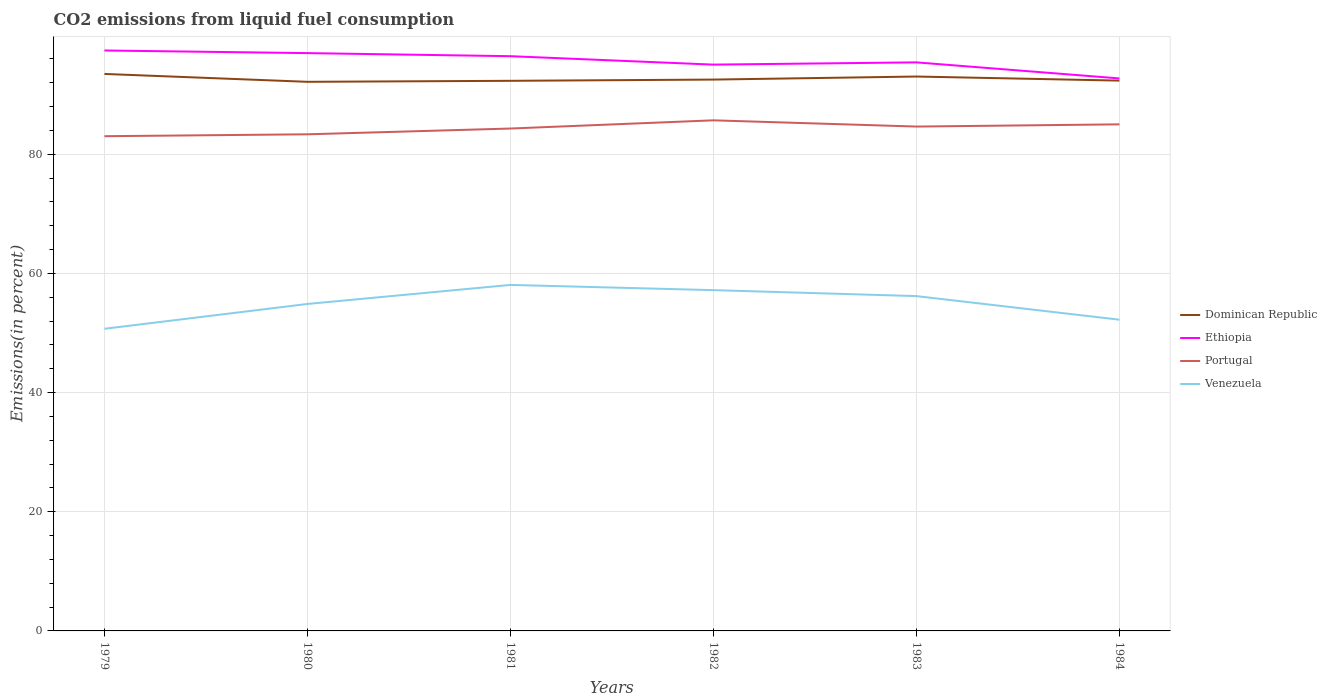How many different coloured lines are there?
Offer a terse response. 4. Does the line corresponding to Dominican Republic intersect with the line corresponding to Venezuela?
Make the answer very short. No. Across all years, what is the maximum total CO2 emitted in Ethiopia?
Ensure brevity in your answer.  92.73. In which year was the total CO2 emitted in Venezuela maximum?
Your response must be concise. 1979. What is the total total CO2 emitted in Portugal in the graph?
Ensure brevity in your answer.  -1.37. What is the difference between the highest and the second highest total CO2 emitted in Portugal?
Ensure brevity in your answer.  2.66. What is the difference between the highest and the lowest total CO2 emitted in Venezuela?
Your answer should be compact. 3. Is the total CO2 emitted in Dominican Republic strictly greater than the total CO2 emitted in Ethiopia over the years?
Make the answer very short. Yes. How many years are there in the graph?
Keep it short and to the point. 6. Are the values on the major ticks of Y-axis written in scientific E-notation?
Give a very brief answer. No. Does the graph contain any zero values?
Provide a short and direct response. No. How are the legend labels stacked?
Ensure brevity in your answer.  Vertical. What is the title of the graph?
Offer a very short reply. CO2 emissions from liquid fuel consumption. What is the label or title of the X-axis?
Give a very brief answer. Years. What is the label or title of the Y-axis?
Your answer should be very brief. Emissions(in percent). What is the Emissions(in percent) of Dominican Republic in 1979?
Offer a very short reply. 93.48. What is the Emissions(in percent) of Ethiopia in 1979?
Make the answer very short. 97.42. What is the Emissions(in percent) of Portugal in 1979?
Provide a succinct answer. 83.04. What is the Emissions(in percent) in Venezuela in 1979?
Offer a very short reply. 50.71. What is the Emissions(in percent) in Dominican Republic in 1980?
Keep it short and to the point. 92.16. What is the Emissions(in percent) in Ethiopia in 1980?
Provide a short and direct response. 96.98. What is the Emissions(in percent) in Portugal in 1980?
Provide a succinct answer. 83.35. What is the Emissions(in percent) in Venezuela in 1980?
Your answer should be compact. 54.88. What is the Emissions(in percent) of Dominican Republic in 1981?
Provide a succinct answer. 92.33. What is the Emissions(in percent) of Ethiopia in 1981?
Provide a short and direct response. 96.46. What is the Emissions(in percent) in Portugal in 1981?
Your response must be concise. 84.32. What is the Emissions(in percent) of Venezuela in 1981?
Make the answer very short. 58.07. What is the Emissions(in percent) in Dominican Republic in 1982?
Your response must be concise. 92.54. What is the Emissions(in percent) in Ethiopia in 1982?
Provide a short and direct response. 95.05. What is the Emissions(in percent) in Portugal in 1982?
Keep it short and to the point. 85.7. What is the Emissions(in percent) of Venezuela in 1982?
Offer a very short reply. 57.2. What is the Emissions(in percent) of Dominican Republic in 1983?
Offer a very short reply. 93.05. What is the Emissions(in percent) in Ethiopia in 1983?
Offer a terse response. 95.43. What is the Emissions(in percent) in Portugal in 1983?
Your answer should be compact. 84.65. What is the Emissions(in percent) in Venezuela in 1983?
Keep it short and to the point. 56.2. What is the Emissions(in percent) in Dominican Republic in 1984?
Your answer should be very brief. 92.36. What is the Emissions(in percent) of Ethiopia in 1984?
Keep it short and to the point. 92.73. What is the Emissions(in percent) of Portugal in 1984?
Make the answer very short. 85.02. What is the Emissions(in percent) in Venezuela in 1984?
Provide a succinct answer. 52.24. Across all years, what is the maximum Emissions(in percent) in Dominican Republic?
Provide a succinct answer. 93.48. Across all years, what is the maximum Emissions(in percent) of Ethiopia?
Make the answer very short. 97.42. Across all years, what is the maximum Emissions(in percent) in Portugal?
Provide a succinct answer. 85.7. Across all years, what is the maximum Emissions(in percent) in Venezuela?
Offer a very short reply. 58.07. Across all years, what is the minimum Emissions(in percent) of Dominican Republic?
Your answer should be very brief. 92.16. Across all years, what is the minimum Emissions(in percent) in Ethiopia?
Offer a terse response. 92.73. Across all years, what is the minimum Emissions(in percent) of Portugal?
Your response must be concise. 83.04. Across all years, what is the minimum Emissions(in percent) of Venezuela?
Provide a succinct answer. 50.71. What is the total Emissions(in percent) of Dominican Republic in the graph?
Keep it short and to the point. 555.93. What is the total Emissions(in percent) in Ethiopia in the graph?
Your answer should be compact. 574.07. What is the total Emissions(in percent) of Portugal in the graph?
Give a very brief answer. 506.09. What is the total Emissions(in percent) in Venezuela in the graph?
Give a very brief answer. 329.29. What is the difference between the Emissions(in percent) of Dominican Republic in 1979 and that in 1980?
Offer a very short reply. 1.32. What is the difference between the Emissions(in percent) in Ethiopia in 1979 and that in 1980?
Offer a very short reply. 0.44. What is the difference between the Emissions(in percent) in Portugal in 1979 and that in 1980?
Your answer should be compact. -0.32. What is the difference between the Emissions(in percent) of Venezuela in 1979 and that in 1980?
Your answer should be compact. -4.17. What is the difference between the Emissions(in percent) in Dominican Republic in 1979 and that in 1981?
Offer a very short reply. 1.15. What is the difference between the Emissions(in percent) in Ethiopia in 1979 and that in 1981?
Offer a very short reply. 0.96. What is the difference between the Emissions(in percent) of Portugal in 1979 and that in 1981?
Keep it short and to the point. -1.29. What is the difference between the Emissions(in percent) in Venezuela in 1979 and that in 1981?
Your answer should be compact. -7.36. What is the difference between the Emissions(in percent) of Dominican Republic in 1979 and that in 1982?
Offer a very short reply. 0.95. What is the difference between the Emissions(in percent) of Ethiopia in 1979 and that in 1982?
Offer a terse response. 2.37. What is the difference between the Emissions(in percent) of Portugal in 1979 and that in 1982?
Keep it short and to the point. -2.66. What is the difference between the Emissions(in percent) in Venezuela in 1979 and that in 1982?
Provide a short and direct response. -6.49. What is the difference between the Emissions(in percent) in Dominican Republic in 1979 and that in 1983?
Your answer should be compact. 0.43. What is the difference between the Emissions(in percent) of Ethiopia in 1979 and that in 1983?
Make the answer very short. 1.99. What is the difference between the Emissions(in percent) in Portugal in 1979 and that in 1983?
Make the answer very short. -1.62. What is the difference between the Emissions(in percent) of Venezuela in 1979 and that in 1983?
Make the answer very short. -5.49. What is the difference between the Emissions(in percent) in Dominican Republic in 1979 and that in 1984?
Keep it short and to the point. 1.12. What is the difference between the Emissions(in percent) of Ethiopia in 1979 and that in 1984?
Your response must be concise. 4.69. What is the difference between the Emissions(in percent) in Portugal in 1979 and that in 1984?
Ensure brevity in your answer.  -1.99. What is the difference between the Emissions(in percent) in Venezuela in 1979 and that in 1984?
Provide a short and direct response. -1.53. What is the difference between the Emissions(in percent) of Dominican Republic in 1980 and that in 1981?
Your response must be concise. -0.17. What is the difference between the Emissions(in percent) of Ethiopia in 1980 and that in 1981?
Make the answer very short. 0.52. What is the difference between the Emissions(in percent) in Portugal in 1980 and that in 1981?
Give a very brief answer. -0.97. What is the difference between the Emissions(in percent) in Venezuela in 1980 and that in 1981?
Make the answer very short. -3.2. What is the difference between the Emissions(in percent) of Dominican Republic in 1980 and that in 1982?
Your response must be concise. -0.38. What is the difference between the Emissions(in percent) in Ethiopia in 1980 and that in 1982?
Keep it short and to the point. 1.93. What is the difference between the Emissions(in percent) in Portugal in 1980 and that in 1982?
Offer a very short reply. -2.34. What is the difference between the Emissions(in percent) in Venezuela in 1980 and that in 1982?
Offer a very short reply. -2.32. What is the difference between the Emissions(in percent) in Dominican Republic in 1980 and that in 1983?
Your answer should be very brief. -0.89. What is the difference between the Emissions(in percent) of Ethiopia in 1980 and that in 1983?
Ensure brevity in your answer.  1.55. What is the difference between the Emissions(in percent) of Portugal in 1980 and that in 1983?
Offer a terse response. -1.3. What is the difference between the Emissions(in percent) in Venezuela in 1980 and that in 1983?
Keep it short and to the point. -1.32. What is the difference between the Emissions(in percent) in Dominican Republic in 1980 and that in 1984?
Give a very brief answer. -0.2. What is the difference between the Emissions(in percent) in Ethiopia in 1980 and that in 1984?
Your answer should be very brief. 4.25. What is the difference between the Emissions(in percent) in Portugal in 1980 and that in 1984?
Your answer should be compact. -1.67. What is the difference between the Emissions(in percent) of Venezuela in 1980 and that in 1984?
Your answer should be very brief. 2.64. What is the difference between the Emissions(in percent) of Dominican Republic in 1981 and that in 1982?
Your answer should be very brief. -0.21. What is the difference between the Emissions(in percent) of Ethiopia in 1981 and that in 1982?
Offer a terse response. 1.41. What is the difference between the Emissions(in percent) in Portugal in 1981 and that in 1982?
Give a very brief answer. -1.37. What is the difference between the Emissions(in percent) in Venezuela in 1981 and that in 1982?
Offer a very short reply. 0.88. What is the difference between the Emissions(in percent) in Dominican Republic in 1981 and that in 1983?
Your answer should be very brief. -0.72. What is the difference between the Emissions(in percent) in Ethiopia in 1981 and that in 1983?
Ensure brevity in your answer.  1.04. What is the difference between the Emissions(in percent) in Portugal in 1981 and that in 1983?
Your answer should be very brief. -0.33. What is the difference between the Emissions(in percent) in Venezuela in 1981 and that in 1983?
Offer a terse response. 1.88. What is the difference between the Emissions(in percent) in Dominican Republic in 1981 and that in 1984?
Make the answer very short. -0.03. What is the difference between the Emissions(in percent) in Ethiopia in 1981 and that in 1984?
Give a very brief answer. 3.73. What is the difference between the Emissions(in percent) in Portugal in 1981 and that in 1984?
Your response must be concise. -0.7. What is the difference between the Emissions(in percent) of Venezuela in 1981 and that in 1984?
Offer a very short reply. 5.84. What is the difference between the Emissions(in percent) of Dominican Republic in 1982 and that in 1983?
Your response must be concise. -0.51. What is the difference between the Emissions(in percent) in Ethiopia in 1982 and that in 1983?
Ensure brevity in your answer.  -0.38. What is the difference between the Emissions(in percent) in Portugal in 1982 and that in 1983?
Offer a terse response. 1.04. What is the difference between the Emissions(in percent) in Venezuela in 1982 and that in 1983?
Make the answer very short. 1. What is the difference between the Emissions(in percent) of Dominican Republic in 1982 and that in 1984?
Keep it short and to the point. 0.17. What is the difference between the Emissions(in percent) in Ethiopia in 1982 and that in 1984?
Offer a terse response. 2.32. What is the difference between the Emissions(in percent) of Portugal in 1982 and that in 1984?
Your answer should be compact. 0.67. What is the difference between the Emissions(in percent) in Venezuela in 1982 and that in 1984?
Your answer should be very brief. 4.96. What is the difference between the Emissions(in percent) of Dominican Republic in 1983 and that in 1984?
Make the answer very short. 0.68. What is the difference between the Emissions(in percent) of Ethiopia in 1983 and that in 1984?
Your answer should be very brief. 2.7. What is the difference between the Emissions(in percent) in Portugal in 1983 and that in 1984?
Make the answer very short. -0.37. What is the difference between the Emissions(in percent) in Venezuela in 1983 and that in 1984?
Provide a short and direct response. 3.96. What is the difference between the Emissions(in percent) of Dominican Republic in 1979 and the Emissions(in percent) of Ethiopia in 1980?
Offer a very short reply. -3.5. What is the difference between the Emissions(in percent) of Dominican Republic in 1979 and the Emissions(in percent) of Portugal in 1980?
Keep it short and to the point. 10.13. What is the difference between the Emissions(in percent) of Dominican Republic in 1979 and the Emissions(in percent) of Venezuela in 1980?
Ensure brevity in your answer.  38.61. What is the difference between the Emissions(in percent) of Ethiopia in 1979 and the Emissions(in percent) of Portugal in 1980?
Give a very brief answer. 14.07. What is the difference between the Emissions(in percent) in Ethiopia in 1979 and the Emissions(in percent) in Venezuela in 1980?
Ensure brevity in your answer.  42.54. What is the difference between the Emissions(in percent) of Portugal in 1979 and the Emissions(in percent) of Venezuela in 1980?
Your answer should be compact. 28.16. What is the difference between the Emissions(in percent) of Dominican Republic in 1979 and the Emissions(in percent) of Ethiopia in 1981?
Keep it short and to the point. -2.98. What is the difference between the Emissions(in percent) in Dominican Republic in 1979 and the Emissions(in percent) in Portugal in 1981?
Your response must be concise. 9.16. What is the difference between the Emissions(in percent) in Dominican Republic in 1979 and the Emissions(in percent) in Venezuela in 1981?
Make the answer very short. 35.41. What is the difference between the Emissions(in percent) in Ethiopia in 1979 and the Emissions(in percent) in Portugal in 1981?
Your answer should be compact. 13.1. What is the difference between the Emissions(in percent) of Ethiopia in 1979 and the Emissions(in percent) of Venezuela in 1981?
Offer a terse response. 39.35. What is the difference between the Emissions(in percent) of Portugal in 1979 and the Emissions(in percent) of Venezuela in 1981?
Make the answer very short. 24.96. What is the difference between the Emissions(in percent) in Dominican Republic in 1979 and the Emissions(in percent) in Ethiopia in 1982?
Offer a very short reply. -1.57. What is the difference between the Emissions(in percent) in Dominican Republic in 1979 and the Emissions(in percent) in Portugal in 1982?
Make the answer very short. 7.79. What is the difference between the Emissions(in percent) in Dominican Republic in 1979 and the Emissions(in percent) in Venezuela in 1982?
Your answer should be compact. 36.29. What is the difference between the Emissions(in percent) in Ethiopia in 1979 and the Emissions(in percent) in Portugal in 1982?
Give a very brief answer. 11.72. What is the difference between the Emissions(in percent) in Ethiopia in 1979 and the Emissions(in percent) in Venezuela in 1982?
Your response must be concise. 40.22. What is the difference between the Emissions(in percent) in Portugal in 1979 and the Emissions(in percent) in Venezuela in 1982?
Your response must be concise. 25.84. What is the difference between the Emissions(in percent) in Dominican Republic in 1979 and the Emissions(in percent) in Ethiopia in 1983?
Keep it short and to the point. -1.94. What is the difference between the Emissions(in percent) of Dominican Republic in 1979 and the Emissions(in percent) of Portugal in 1983?
Keep it short and to the point. 8.83. What is the difference between the Emissions(in percent) in Dominican Republic in 1979 and the Emissions(in percent) in Venezuela in 1983?
Keep it short and to the point. 37.29. What is the difference between the Emissions(in percent) of Ethiopia in 1979 and the Emissions(in percent) of Portugal in 1983?
Ensure brevity in your answer.  12.77. What is the difference between the Emissions(in percent) of Ethiopia in 1979 and the Emissions(in percent) of Venezuela in 1983?
Offer a terse response. 41.22. What is the difference between the Emissions(in percent) of Portugal in 1979 and the Emissions(in percent) of Venezuela in 1983?
Provide a succinct answer. 26.84. What is the difference between the Emissions(in percent) of Dominican Republic in 1979 and the Emissions(in percent) of Ethiopia in 1984?
Your answer should be very brief. 0.75. What is the difference between the Emissions(in percent) in Dominican Republic in 1979 and the Emissions(in percent) in Portugal in 1984?
Provide a short and direct response. 8.46. What is the difference between the Emissions(in percent) in Dominican Republic in 1979 and the Emissions(in percent) in Venezuela in 1984?
Your answer should be very brief. 41.25. What is the difference between the Emissions(in percent) of Ethiopia in 1979 and the Emissions(in percent) of Portugal in 1984?
Keep it short and to the point. 12.4. What is the difference between the Emissions(in percent) in Ethiopia in 1979 and the Emissions(in percent) in Venezuela in 1984?
Offer a terse response. 45.18. What is the difference between the Emissions(in percent) in Portugal in 1979 and the Emissions(in percent) in Venezuela in 1984?
Your answer should be very brief. 30.8. What is the difference between the Emissions(in percent) in Dominican Republic in 1980 and the Emissions(in percent) in Ethiopia in 1981?
Provide a succinct answer. -4.3. What is the difference between the Emissions(in percent) of Dominican Republic in 1980 and the Emissions(in percent) of Portugal in 1981?
Your answer should be compact. 7.84. What is the difference between the Emissions(in percent) of Dominican Republic in 1980 and the Emissions(in percent) of Venezuela in 1981?
Keep it short and to the point. 34.09. What is the difference between the Emissions(in percent) in Ethiopia in 1980 and the Emissions(in percent) in Portugal in 1981?
Keep it short and to the point. 12.66. What is the difference between the Emissions(in percent) in Ethiopia in 1980 and the Emissions(in percent) in Venezuela in 1981?
Offer a very short reply. 38.91. What is the difference between the Emissions(in percent) in Portugal in 1980 and the Emissions(in percent) in Venezuela in 1981?
Your response must be concise. 25.28. What is the difference between the Emissions(in percent) of Dominican Republic in 1980 and the Emissions(in percent) of Ethiopia in 1982?
Your answer should be compact. -2.89. What is the difference between the Emissions(in percent) of Dominican Republic in 1980 and the Emissions(in percent) of Portugal in 1982?
Keep it short and to the point. 6.47. What is the difference between the Emissions(in percent) of Dominican Republic in 1980 and the Emissions(in percent) of Venezuela in 1982?
Ensure brevity in your answer.  34.97. What is the difference between the Emissions(in percent) of Ethiopia in 1980 and the Emissions(in percent) of Portugal in 1982?
Your answer should be very brief. 11.28. What is the difference between the Emissions(in percent) in Ethiopia in 1980 and the Emissions(in percent) in Venezuela in 1982?
Provide a succinct answer. 39.79. What is the difference between the Emissions(in percent) of Portugal in 1980 and the Emissions(in percent) of Venezuela in 1982?
Provide a short and direct response. 26.16. What is the difference between the Emissions(in percent) in Dominican Republic in 1980 and the Emissions(in percent) in Ethiopia in 1983?
Your response must be concise. -3.26. What is the difference between the Emissions(in percent) in Dominican Republic in 1980 and the Emissions(in percent) in Portugal in 1983?
Offer a very short reply. 7.51. What is the difference between the Emissions(in percent) of Dominican Republic in 1980 and the Emissions(in percent) of Venezuela in 1983?
Ensure brevity in your answer.  35.97. What is the difference between the Emissions(in percent) in Ethiopia in 1980 and the Emissions(in percent) in Portugal in 1983?
Your answer should be very brief. 12.33. What is the difference between the Emissions(in percent) in Ethiopia in 1980 and the Emissions(in percent) in Venezuela in 1983?
Offer a terse response. 40.78. What is the difference between the Emissions(in percent) in Portugal in 1980 and the Emissions(in percent) in Venezuela in 1983?
Your answer should be compact. 27.16. What is the difference between the Emissions(in percent) in Dominican Republic in 1980 and the Emissions(in percent) in Ethiopia in 1984?
Keep it short and to the point. -0.57. What is the difference between the Emissions(in percent) of Dominican Republic in 1980 and the Emissions(in percent) of Portugal in 1984?
Keep it short and to the point. 7.14. What is the difference between the Emissions(in percent) in Dominican Republic in 1980 and the Emissions(in percent) in Venezuela in 1984?
Your answer should be compact. 39.93. What is the difference between the Emissions(in percent) of Ethiopia in 1980 and the Emissions(in percent) of Portugal in 1984?
Provide a succinct answer. 11.96. What is the difference between the Emissions(in percent) of Ethiopia in 1980 and the Emissions(in percent) of Venezuela in 1984?
Your response must be concise. 44.75. What is the difference between the Emissions(in percent) of Portugal in 1980 and the Emissions(in percent) of Venezuela in 1984?
Make the answer very short. 31.12. What is the difference between the Emissions(in percent) in Dominican Republic in 1981 and the Emissions(in percent) in Ethiopia in 1982?
Give a very brief answer. -2.72. What is the difference between the Emissions(in percent) in Dominican Republic in 1981 and the Emissions(in percent) in Portugal in 1982?
Give a very brief answer. 6.63. What is the difference between the Emissions(in percent) in Dominican Republic in 1981 and the Emissions(in percent) in Venezuela in 1982?
Give a very brief answer. 35.13. What is the difference between the Emissions(in percent) in Ethiopia in 1981 and the Emissions(in percent) in Portugal in 1982?
Provide a succinct answer. 10.77. What is the difference between the Emissions(in percent) of Ethiopia in 1981 and the Emissions(in percent) of Venezuela in 1982?
Offer a terse response. 39.27. What is the difference between the Emissions(in percent) in Portugal in 1981 and the Emissions(in percent) in Venezuela in 1982?
Make the answer very short. 27.13. What is the difference between the Emissions(in percent) of Dominican Republic in 1981 and the Emissions(in percent) of Ethiopia in 1983?
Provide a succinct answer. -3.1. What is the difference between the Emissions(in percent) in Dominican Republic in 1981 and the Emissions(in percent) in Portugal in 1983?
Your response must be concise. 7.68. What is the difference between the Emissions(in percent) in Dominican Republic in 1981 and the Emissions(in percent) in Venezuela in 1983?
Your answer should be very brief. 36.13. What is the difference between the Emissions(in percent) of Ethiopia in 1981 and the Emissions(in percent) of Portugal in 1983?
Your answer should be very brief. 11.81. What is the difference between the Emissions(in percent) in Ethiopia in 1981 and the Emissions(in percent) in Venezuela in 1983?
Your answer should be very brief. 40.27. What is the difference between the Emissions(in percent) of Portugal in 1981 and the Emissions(in percent) of Venezuela in 1983?
Your answer should be compact. 28.13. What is the difference between the Emissions(in percent) of Dominican Republic in 1981 and the Emissions(in percent) of Ethiopia in 1984?
Give a very brief answer. -0.4. What is the difference between the Emissions(in percent) of Dominican Republic in 1981 and the Emissions(in percent) of Portugal in 1984?
Provide a short and direct response. 7.31. What is the difference between the Emissions(in percent) in Dominican Republic in 1981 and the Emissions(in percent) in Venezuela in 1984?
Your answer should be very brief. 40.09. What is the difference between the Emissions(in percent) in Ethiopia in 1981 and the Emissions(in percent) in Portugal in 1984?
Keep it short and to the point. 11.44. What is the difference between the Emissions(in percent) in Ethiopia in 1981 and the Emissions(in percent) in Venezuela in 1984?
Your answer should be very brief. 44.23. What is the difference between the Emissions(in percent) of Portugal in 1981 and the Emissions(in percent) of Venezuela in 1984?
Give a very brief answer. 32.09. What is the difference between the Emissions(in percent) in Dominican Republic in 1982 and the Emissions(in percent) in Ethiopia in 1983?
Keep it short and to the point. -2.89. What is the difference between the Emissions(in percent) of Dominican Republic in 1982 and the Emissions(in percent) of Portugal in 1983?
Offer a terse response. 7.89. What is the difference between the Emissions(in percent) of Dominican Republic in 1982 and the Emissions(in percent) of Venezuela in 1983?
Your answer should be compact. 36.34. What is the difference between the Emissions(in percent) in Ethiopia in 1982 and the Emissions(in percent) in Portugal in 1983?
Offer a very short reply. 10.4. What is the difference between the Emissions(in percent) of Ethiopia in 1982 and the Emissions(in percent) of Venezuela in 1983?
Your answer should be compact. 38.85. What is the difference between the Emissions(in percent) of Portugal in 1982 and the Emissions(in percent) of Venezuela in 1983?
Offer a terse response. 29.5. What is the difference between the Emissions(in percent) in Dominican Republic in 1982 and the Emissions(in percent) in Ethiopia in 1984?
Your answer should be compact. -0.19. What is the difference between the Emissions(in percent) of Dominican Republic in 1982 and the Emissions(in percent) of Portugal in 1984?
Your answer should be compact. 7.52. What is the difference between the Emissions(in percent) of Dominican Republic in 1982 and the Emissions(in percent) of Venezuela in 1984?
Keep it short and to the point. 40.3. What is the difference between the Emissions(in percent) of Ethiopia in 1982 and the Emissions(in percent) of Portugal in 1984?
Offer a terse response. 10.03. What is the difference between the Emissions(in percent) in Ethiopia in 1982 and the Emissions(in percent) in Venezuela in 1984?
Give a very brief answer. 42.81. What is the difference between the Emissions(in percent) in Portugal in 1982 and the Emissions(in percent) in Venezuela in 1984?
Make the answer very short. 33.46. What is the difference between the Emissions(in percent) in Dominican Republic in 1983 and the Emissions(in percent) in Ethiopia in 1984?
Your answer should be very brief. 0.32. What is the difference between the Emissions(in percent) of Dominican Republic in 1983 and the Emissions(in percent) of Portugal in 1984?
Your answer should be very brief. 8.03. What is the difference between the Emissions(in percent) in Dominican Republic in 1983 and the Emissions(in percent) in Venezuela in 1984?
Offer a very short reply. 40.81. What is the difference between the Emissions(in percent) in Ethiopia in 1983 and the Emissions(in percent) in Portugal in 1984?
Offer a very short reply. 10.4. What is the difference between the Emissions(in percent) of Ethiopia in 1983 and the Emissions(in percent) of Venezuela in 1984?
Keep it short and to the point. 43.19. What is the difference between the Emissions(in percent) of Portugal in 1983 and the Emissions(in percent) of Venezuela in 1984?
Keep it short and to the point. 32.42. What is the average Emissions(in percent) of Dominican Republic per year?
Keep it short and to the point. 92.66. What is the average Emissions(in percent) in Ethiopia per year?
Ensure brevity in your answer.  95.68. What is the average Emissions(in percent) of Portugal per year?
Offer a very short reply. 84.35. What is the average Emissions(in percent) of Venezuela per year?
Provide a succinct answer. 54.88. In the year 1979, what is the difference between the Emissions(in percent) of Dominican Republic and Emissions(in percent) of Ethiopia?
Give a very brief answer. -3.94. In the year 1979, what is the difference between the Emissions(in percent) of Dominican Republic and Emissions(in percent) of Portugal?
Provide a succinct answer. 10.45. In the year 1979, what is the difference between the Emissions(in percent) of Dominican Republic and Emissions(in percent) of Venezuela?
Provide a succinct answer. 42.77. In the year 1979, what is the difference between the Emissions(in percent) of Ethiopia and Emissions(in percent) of Portugal?
Your answer should be compact. 14.39. In the year 1979, what is the difference between the Emissions(in percent) of Ethiopia and Emissions(in percent) of Venezuela?
Keep it short and to the point. 46.71. In the year 1979, what is the difference between the Emissions(in percent) of Portugal and Emissions(in percent) of Venezuela?
Offer a terse response. 32.32. In the year 1980, what is the difference between the Emissions(in percent) of Dominican Republic and Emissions(in percent) of Ethiopia?
Keep it short and to the point. -4.82. In the year 1980, what is the difference between the Emissions(in percent) of Dominican Republic and Emissions(in percent) of Portugal?
Ensure brevity in your answer.  8.81. In the year 1980, what is the difference between the Emissions(in percent) of Dominican Republic and Emissions(in percent) of Venezuela?
Offer a terse response. 37.29. In the year 1980, what is the difference between the Emissions(in percent) in Ethiopia and Emissions(in percent) in Portugal?
Your response must be concise. 13.63. In the year 1980, what is the difference between the Emissions(in percent) of Ethiopia and Emissions(in percent) of Venezuela?
Provide a succinct answer. 42.1. In the year 1980, what is the difference between the Emissions(in percent) of Portugal and Emissions(in percent) of Venezuela?
Make the answer very short. 28.48. In the year 1981, what is the difference between the Emissions(in percent) in Dominican Republic and Emissions(in percent) in Ethiopia?
Your answer should be very brief. -4.13. In the year 1981, what is the difference between the Emissions(in percent) in Dominican Republic and Emissions(in percent) in Portugal?
Offer a very short reply. 8.01. In the year 1981, what is the difference between the Emissions(in percent) of Dominican Republic and Emissions(in percent) of Venezuela?
Your answer should be very brief. 34.26. In the year 1981, what is the difference between the Emissions(in percent) of Ethiopia and Emissions(in percent) of Portugal?
Make the answer very short. 12.14. In the year 1981, what is the difference between the Emissions(in percent) in Ethiopia and Emissions(in percent) in Venezuela?
Offer a terse response. 38.39. In the year 1981, what is the difference between the Emissions(in percent) in Portugal and Emissions(in percent) in Venezuela?
Give a very brief answer. 26.25. In the year 1982, what is the difference between the Emissions(in percent) in Dominican Republic and Emissions(in percent) in Ethiopia?
Offer a very short reply. -2.51. In the year 1982, what is the difference between the Emissions(in percent) of Dominican Republic and Emissions(in percent) of Portugal?
Provide a succinct answer. 6.84. In the year 1982, what is the difference between the Emissions(in percent) of Dominican Republic and Emissions(in percent) of Venezuela?
Keep it short and to the point. 35.34. In the year 1982, what is the difference between the Emissions(in percent) of Ethiopia and Emissions(in percent) of Portugal?
Give a very brief answer. 9.35. In the year 1982, what is the difference between the Emissions(in percent) in Ethiopia and Emissions(in percent) in Venezuela?
Your response must be concise. 37.85. In the year 1982, what is the difference between the Emissions(in percent) in Portugal and Emissions(in percent) in Venezuela?
Your response must be concise. 28.5. In the year 1983, what is the difference between the Emissions(in percent) in Dominican Republic and Emissions(in percent) in Ethiopia?
Give a very brief answer. -2.38. In the year 1983, what is the difference between the Emissions(in percent) in Dominican Republic and Emissions(in percent) in Portugal?
Your answer should be compact. 8.4. In the year 1983, what is the difference between the Emissions(in percent) of Dominican Republic and Emissions(in percent) of Venezuela?
Make the answer very short. 36.85. In the year 1983, what is the difference between the Emissions(in percent) in Ethiopia and Emissions(in percent) in Portugal?
Your answer should be very brief. 10.77. In the year 1983, what is the difference between the Emissions(in percent) of Ethiopia and Emissions(in percent) of Venezuela?
Keep it short and to the point. 39.23. In the year 1983, what is the difference between the Emissions(in percent) of Portugal and Emissions(in percent) of Venezuela?
Make the answer very short. 28.46. In the year 1984, what is the difference between the Emissions(in percent) of Dominican Republic and Emissions(in percent) of Ethiopia?
Offer a very short reply. -0.37. In the year 1984, what is the difference between the Emissions(in percent) in Dominican Republic and Emissions(in percent) in Portugal?
Your response must be concise. 7.34. In the year 1984, what is the difference between the Emissions(in percent) in Dominican Republic and Emissions(in percent) in Venezuela?
Ensure brevity in your answer.  40.13. In the year 1984, what is the difference between the Emissions(in percent) of Ethiopia and Emissions(in percent) of Portugal?
Offer a terse response. 7.71. In the year 1984, what is the difference between the Emissions(in percent) of Ethiopia and Emissions(in percent) of Venezuela?
Make the answer very short. 40.49. In the year 1984, what is the difference between the Emissions(in percent) in Portugal and Emissions(in percent) in Venezuela?
Make the answer very short. 32.79. What is the ratio of the Emissions(in percent) in Dominican Republic in 1979 to that in 1980?
Give a very brief answer. 1.01. What is the ratio of the Emissions(in percent) in Portugal in 1979 to that in 1980?
Make the answer very short. 1. What is the ratio of the Emissions(in percent) in Venezuela in 1979 to that in 1980?
Offer a very short reply. 0.92. What is the ratio of the Emissions(in percent) in Dominican Republic in 1979 to that in 1981?
Your answer should be very brief. 1.01. What is the ratio of the Emissions(in percent) of Ethiopia in 1979 to that in 1981?
Keep it short and to the point. 1.01. What is the ratio of the Emissions(in percent) in Portugal in 1979 to that in 1981?
Your answer should be compact. 0.98. What is the ratio of the Emissions(in percent) in Venezuela in 1979 to that in 1981?
Your answer should be compact. 0.87. What is the ratio of the Emissions(in percent) in Dominican Republic in 1979 to that in 1982?
Offer a terse response. 1.01. What is the ratio of the Emissions(in percent) of Ethiopia in 1979 to that in 1982?
Your answer should be very brief. 1.02. What is the ratio of the Emissions(in percent) of Portugal in 1979 to that in 1982?
Make the answer very short. 0.97. What is the ratio of the Emissions(in percent) of Venezuela in 1979 to that in 1982?
Offer a very short reply. 0.89. What is the ratio of the Emissions(in percent) of Dominican Republic in 1979 to that in 1983?
Give a very brief answer. 1. What is the ratio of the Emissions(in percent) in Ethiopia in 1979 to that in 1983?
Offer a terse response. 1.02. What is the ratio of the Emissions(in percent) of Portugal in 1979 to that in 1983?
Keep it short and to the point. 0.98. What is the ratio of the Emissions(in percent) of Venezuela in 1979 to that in 1983?
Your answer should be very brief. 0.9. What is the ratio of the Emissions(in percent) of Dominican Republic in 1979 to that in 1984?
Give a very brief answer. 1.01. What is the ratio of the Emissions(in percent) of Ethiopia in 1979 to that in 1984?
Ensure brevity in your answer.  1.05. What is the ratio of the Emissions(in percent) of Portugal in 1979 to that in 1984?
Offer a terse response. 0.98. What is the ratio of the Emissions(in percent) of Venezuela in 1979 to that in 1984?
Your response must be concise. 0.97. What is the ratio of the Emissions(in percent) of Ethiopia in 1980 to that in 1981?
Provide a succinct answer. 1.01. What is the ratio of the Emissions(in percent) in Venezuela in 1980 to that in 1981?
Provide a succinct answer. 0.94. What is the ratio of the Emissions(in percent) of Ethiopia in 1980 to that in 1982?
Give a very brief answer. 1.02. What is the ratio of the Emissions(in percent) of Portugal in 1980 to that in 1982?
Give a very brief answer. 0.97. What is the ratio of the Emissions(in percent) of Venezuela in 1980 to that in 1982?
Keep it short and to the point. 0.96. What is the ratio of the Emissions(in percent) in Ethiopia in 1980 to that in 1983?
Provide a succinct answer. 1.02. What is the ratio of the Emissions(in percent) of Portugal in 1980 to that in 1983?
Offer a very short reply. 0.98. What is the ratio of the Emissions(in percent) in Venezuela in 1980 to that in 1983?
Provide a succinct answer. 0.98. What is the ratio of the Emissions(in percent) of Dominican Republic in 1980 to that in 1984?
Provide a short and direct response. 1. What is the ratio of the Emissions(in percent) of Ethiopia in 1980 to that in 1984?
Provide a succinct answer. 1.05. What is the ratio of the Emissions(in percent) in Portugal in 1980 to that in 1984?
Provide a short and direct response. 0.98. What is the ratio of the Emissions(in percent) of Venezuela in 1980 to that in 1984?
Ensure brevity in your answer.  1.05. What is the ratio of the Emissions(in percent) of Ethiopia in 1981 to that in 1982?
Provide a short and direct response. 1.01. What is the ratio of the Emissions(in percent) of Venezuela in 1981 to that in 1982?
Provide a succinct answer. 1.02. What is the ratio of the Emissions(in percent) in Ethiopia in 1981 to that in 1983?
Ensure brevity in your answer.  1.01. What is the ratio of the Emissions(in percent) of Venezuela in 1981 to that in 1983?
Provide a succinct answer. 1.03. What is the ratio of the Emissions(in percent) of Dominican Republic in 1981 to that in 1984?
Provide a short and direct response. 1. What is the ratio of the Emissions(in percent) of Ethiopia in 1981 to that in 1984?
Provide a succinct answer. 1.04. What is the ratio of the Emissions(in percent) in Venezuela in 1981 to that in 1984?
Provide a succinct answer. 1.11. What is the ratio of the Emissions(in percent) of Dominican Republic in 1982 to that in 1983?
Your answer should be compact. 0.99. What is the ratio of the Emissions(in percent) in Portugal in 1982 to that in 1983?
Make the answer very short. 1.01. What is the ratio of the Emissions(in percent) of Venezuela in 1982 to that in 1983?
Ensure brevity in your answer.  1.02. What is the ratio of the Emissions(in percent) in Dominican Republic in 1982 to that in 1984?
Offer a very short reply. 1. What is the ratio of the Emissions(in percent) of Ethiopia in 1982 to that in 1984?
Your answer should be very brief. 1.02. What is the ratio of the Emissions(in percent) of Portugal in 1982 to that in 1984?
Your answer should be very brief. 1.01. What is the ratio of the Emissions(in percent) of Venezuela in 1982 to that in 1984?
Make the answer very short. 1.09. What is the ratio of the Emissions(in percent) in Dominican Republic in 1983 to that in 1984?
Offer a terse response. 1.01. What is the ratio of the Emissions(in percent) in Ethiopia in 1983 to that in 1984?
Provide a succinct answer. 1.03. What is the ratio of the Emissions(in percent) in Portugal in 1983 to that in 1984?
Provide a succinct answer. 1. What is the ratio of the Emissions(in percent) of Venezuela in 1983 to that in 1984?
Keep it short and to the point. 1.08. What is the difference between the highest and the second highest Emissions(in percent) of Dominican Republic?
Ensure brevity in your answer.  0.43. What is the difference between the highest and the second highest Emissions(in percent) in Ethiopia?
Ensure brevity in your answer.  0.44. What is the difference between the highest and the second highest Emissions(in percent) of Portugal?
Make the answer very short. 0.67. What is the difference between the highest and the second highest Emissions(in percent) of Venezuela?
Keep it short and to the point. 0.88. What is the difference between the highest and the lowest Emissions(in percent) in Dominican Republic?
Your answer should be compact. 1.32. What is the difference between the highest and the lowest Emissions(in percent) of Ethiopia?
Your answer should be compact. 4.69. What is the difference between the highest and the lowest Emissions(in percent) of Portugal?
Your answer should be compact. 2.66. What is the difference between the highest and the lowest Emissions(in percent) in Venezuela?
Your answer should be very brief. 7.36. 